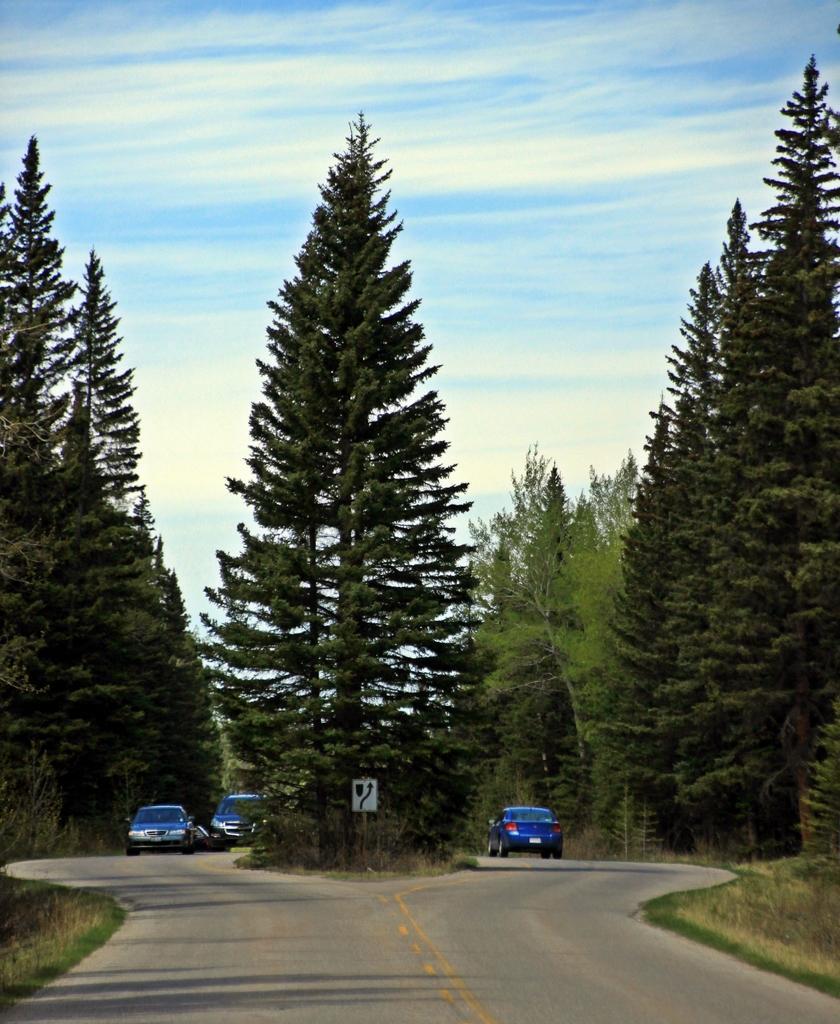Could you give a brief overview of what you see in this image? There is a two way road on which, there are vehicles and there are trees on the divider. On both sides of this road, there is grass, there are plants and trees on the ground. In the background, there are clouds in the blue sky. 